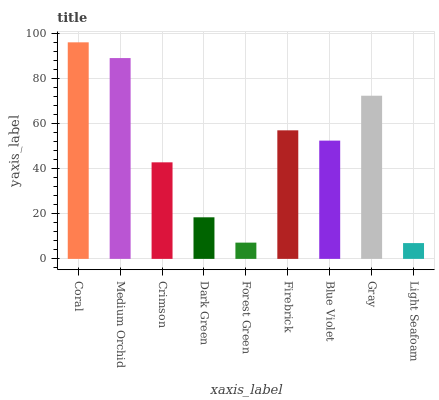Is Medium Orchid the minimum?
Answer yes or no. No. Is Medium Orchid the maximum?
Answer yes or no. No. Is Coral greater than Medium Orchid?
Answer yes or no. Yes. Is Medium Orchid less than Coral?
Answer yes or no. Yes. Is Medium Orchid greater than Coral?
Answer yes or no. No. Is Coral less than Medium Orchid?
Answer yes or no. No. Is Blue Violet the high median?
Answer yes or no. Yes. Is Blue Violet the low median?
Answer yes or no. Yes. Is Light Seafoam the high median?
Answer yes or no. No. Is Coral the low median?
Answer yes or no. No. 